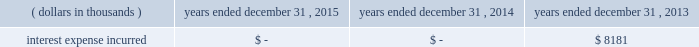Junior subordinated debt securities payable in accordance with the provisions of the junior subordinated debt securities which were issued on march 29 , 2004 , holdings elected to redeem the $ 329897 thousand of 6.2% ( 6.2 % ) junior subordinated debt securities outstanding on may 24 , 2013 .
As a result of the early redemption , the company incurred pre-tax expense of $ 7282 thousand related to the immediate amortization of the remaining capitalized issuance costs on the trust preferred securities .
Interest expense incurred in connection with these junior subordinated debt securities is as follows for the periods indicated: .
Holdings considered the mechanisms and obligations relating to the trust preferred securities , taken together , constituted a full and unconditional guarantee by holdings of capital trust ii 2019s payment obligations with respect to their trust preferred securities .
10 .
Reinsurance and trust agreements certain subsidiaries of group have established trust agreements , which effectively use the company 2019s investments as collateral , as security for assumed losses payable to certain non-affiliated ceding companies .
At december 31 , 2015 , the total amount on deposit in trust accounts was $ 454384 thousand .
On april 24 , 2014 , the company entered into two collateralized reinsurance agreements with kilimanjaro re limited ( 201ckilimanjaro 201d ) , a bermuda based special purpose reinsurer , to provide the company with catastrophe reinsurance coverage .
These agreements are multi-year reinsurance contracts which cover specified named storm and earthquake events .
The first agreement provides up to $ 250000 thousand of reinsurance coverage from named storms in specified states of the southeastern united states .
The second agreement provides up to $ 200000 thousand of reinsurance coverage from named storms in specified states of the southeast , mid-atlantic and northeast regions of the united states and puerto rico as well as reinsurance coverage from earthquakes in specified states of the southeast , mid-atlantic , northeast and west regions of the united states , puerto rico and british columbia .
On november 18 , 2014 , the company entered into a collateralized reinsurance agreement with kilimanjaro re to provide the company with catastrophe reinsurance coverage .
This agreement is a multi-year reinsurance contract which covers specified earthquake events .
The agreement provides up to $ 500000 thousand of reinsurance coverage from earthquakes in the united states , puerto rico and canada .
On december 1 , 2015 the company entered into two collateralized reinsurance agreements with kilimanjaro re to provide the company with catastrophe reinsurance coverage .
These agreements are multi-year reinsurance contracts which cover named storm and earthquake events .
The first agreement provides up to $ 300000 thousand of reinsurance coverage from named storms and earthquakes in the united states , puerto rico and canada .
The second agreement provides up to $ 325000 thousand of reinsurance coverage from named storms and earthquakes in the united states , puerto rico and canada .
Kilimanjaro has financed the various property catastrophe reinsurance coverage by issuing catastrophe bonds to unrelated , external investors .
On april 24 , 2014 , kilimanjaro issued $ 450000 thousand of notes ( 201cseries 2014-1 notes 201d ) .
On november 18 , 2014 , kilimanjaro issued $ 500000 thousand of notes ( 201cseries 2014-2 notes 201d ) .
On december 1 , 2015 , kilimanjaro issued $ 625000 thousand of notes ( 201cseries 2015-1 notes ) .
The proceeds from the issuance of the series 2014-1 notes , the series 2014-2 notes and the series 2015-1 notes are held in reinsurance trust throughout the duration of the applicable reinsurance agreements and invested solely in us government money market funds with a rating of at least 201caaam 201d by standard & poor 2019s. .
In 2014 what was the total amount of catastrophe reinsurance coverage the company obtained in thousands? 
Computations: (200000 + 250000)
Answer: 450000.0. Junior subordinated debt securities payable in accordance with the provisions of the junior subordinated debt securities which were issued on march 29 , 2004 , holdings elected to redeem the $ 329897 thousand of 6.2% ( 6.2 % ) junior subordinated debt securities outstanding on may 24 , 2013 .
As a result of the early redemption , the company incurred pre-tax expense of $ 7282 thousand related to the immediate amortization of the remaining capitalized issuance costs on the trust preferred securities .
Interest expense incurred in connection with these junior subordinated debt securities is as follows for the periods indicated: .
Holdings considered the mechanisms and obligations relating to the trust preferred securities , taken together , constituted a full and unconditional guarantee by holdings of capital trust ii 2019s payment obligations with respect to their trust preferred securities .
10 .
Reinsurance and trust agreements certain subsidiaries of group have established trust agreements , which effectively use the company 2019s investments as collateral , as security for assumed losses payable to certain non-affiliated ceding companies .
At december 31 , 2015 , the total amount on deposit in trust accounts was $ 454384 thousand .
On april 24 , 2014 , the company entered into two collateralized reinsurance agreements with kilimanjaro re limited ( 201ckilimanjaro 201d ) , a bermuda based special purpose reinsurer , to provide the company with catastrophe reinsurance coverage .
These agreements are multi-year reinsurance contracts which cover specified named storm and earthquake events .
The first agreement provides up to $ 250000 thousand of reinsurance coverage from named storms in specified states of the southeastern united states .
The second agreement provides up to $ 200000 thousand of reinsurance coverage from named storms in specified states of the southeast , mid-atlantic and northeast regions of the united states and puerto rico as well as reinsurance coverage from earthquakes in specified states of the southeast , mid-atlantic , northeast and west regions of the united states , puerto rico and british columbia .
On november 18 , 2014 , the company entered into a collateralized reinsurance agreement with kilimanjaro re to provide the company with catastrophe reinsurance coverage .
This agreement is a multi-year reinsurance contract which covers specified earthquake events .
The agreement provides up to $ 500000 thousand of reinsurance coverage from earthquakes in the united states , puerto rico and canada .
On december 1 , 2015 the company entered into two collateralized reinsurance agreements with kilimanjaro re to provide the company with catastrophe reinsurance coverage .
These agreements are multi-year reinsurance contracts which cover named storm and earthquake events .
The first agreement provides up to $ 300000 thousand of reinsurance coverage from named storms and earthquakes in the united states , puerto rico and canada .
The second agreement provides up to $ 325000 thousand of reinsurance coverage from named storms and earthquakes in the united states , puerto rico and canada .
Kilimanjaro has financed the various property catastrophe reinsurance coverage by issuing catastrophe bonds to unrelated , external investors .
On april 24 , 2014 , kilimanjaro issued $ 450000 thousand of notes ( 201cseries 2014-1 notes 201d ) .
On november 18 , 2014 , kilimanjaro issued $ 500000 thousand of notes ( 201cseries 2014-2 notes 201d ) .
On december 1 , 2015 , kilimanjaro issued $ 625000 thousand of notes ( 201cseries 2015-1 notes ) .
The proceeds from the issuance of the series 2014-1 notes , the series 2014-2 notes and the series 2015-1 notes are held in reinsurance trust throughout the duration of the applicable reinsurance agreements and invested solely in us government money market funds with a rating of at least 201caaam 201d by standard & poor 2019s. .
What is the total value of notes issues by kilimanjaro in 2014 and 2015? 
Computations: ((450000 + 500000) + 625000)
Answer: 1575000.0. Junior subordinated debt securities payable in accordance with the provisions of the junior subordinated debt securities which were issued on march 29 , 2004 , holdings elected to redeem the $ 329897 thousand of 6.2% ( 6.2 % ) junior subordinated debt securities outstanding on may 24 , 2013 .
As a result of the early redemption , the company incurred pre-tax expense of $ 7282 thousand related to the immediate amortization of the remaining capitalized issuance costs on the trust preferred securities .
Interest expense incurred in connection with these junior subordinated debt securities is as follows for the periods indicated: .
Holdings considered the mechanisms and obligations relating to the trust preferred securities , taken together , constituted a full and unconditional guarantee by holdings of capital trust ii 2019s payment obligations with respect to their trust preferred securities .
10 .
Reinsurance and trust agreements certain subsidiaries of group have established trust agreements , which effectively use the company 2019s investments as collateral , as security for assumed losses payable to certain non-affiliated ceding companies .
At december 31 , 2015 , the total amount on deposit in trust accounts was $ 454384 thousand .
On april 24 , 2014 , the company entered into two collateralized reinsurance agreements with kilimanjaro re limited ( 201ckilimanjaro 201d ) , a bermuda based special purpose reinsurer , to provide the company with catastrophe reinsurance coverage .
These agreements are multi-year reinsurance contracts which cover specified named storm and earthquake events .
The first agreement provides up to $ 250000 thousand of reinsurance coverage from named storms in specified states of the southeastern united states .
The second agreement provides up to $ 200000 thousand of reinsurance coverage from named storms in specified states of the southeast , mid-atlantic and northeast regions of the united states and puerto rico as well as reinsurance coverage from earthquakes in specified states of the southeast , mid-atlantic , northeast and west regions of the united states , puerto rico and british columbia .
On november 18 , 2014 , the company entered into a collateralized reinsurance agreement with kilimanjaro re to provide the company with catastrophe reinsurance coverage .
This agreement is a multi-year reinsurance contract which covers specified earthquake events .
The agreement provides up to $ 500000 thousand of reinsurance coverage from earthquakes in the united states , puerto rico and canada .
On december 1 , 2015 the company entered into two collateralized reinsurance agreements with kilimanjaro re to provide the company with catastrophe reinsurance coverage .
These agreements are multi-year reinsurance contracts which cover named storm and earthquake events .
The first agreement provides up to $ 300000 thousand of reinsurance coverage from named storms and earthquakes in the united states , puerto rico and canada .
The second agreement provides up to $ 325000 thousand of reinsurance coverage from named storms and earthquakes in the united states , puerto rico and canada .
Kilimanjaro has financed the various property catastrophe reinsurance coverage by issuing catastrophe bonds to unrelated , external investors .
On april 24 , 2014 , kilimanjaro issued $ 450000 thousand of notes ( 201cseries 2014-1 notes 201d ) .
On november 18 , 2014 , kilimanjaro issued $ 500000 thousand of notes ( 201cseries 2014-2 notes 201d ) .
On december 1 , 2015 , kilimanjaro issued $ 625000 thousand of notes ( 201cseries 2015-1 notes ) .
The proceeds from the issuance of the series 2014-1 notes , the series 2014-2 notes and the series 2015-1 notes are held in reinsurance trust throughout the duration of the applicable reinsurance agreements and invested solely in us government money market funds with a rating of at least 201caaam 201d by standard & poor 2019s. .
What was the percent of the pre-tax expense incurred as part of the early redemption to the redemption amount? 
Computations: (7282 / 329897)
Answer: 0.02207. 